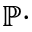Convert formula to latex. <formula><loc_0><loc_0><loc_500><loc_500>\mathbb { P } \cdot</formula> 